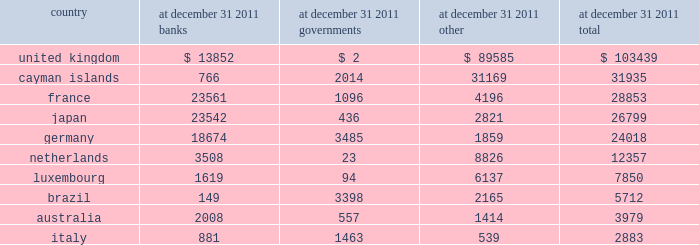Financial data supplement ( unaudited ) 2014 ( continued ) .

How big is south america compared to asia? 
Rationale: brazil - south america , japan - asia
Computations: (5712 / 26799)
Answer: 0.21314. 